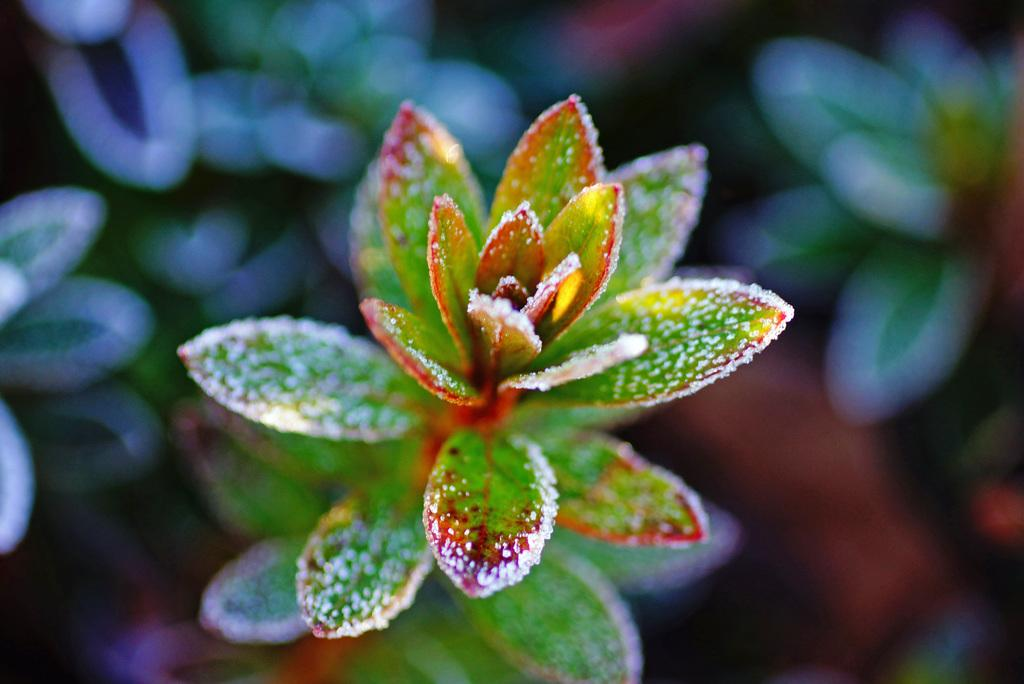What type of plant is represented in the image? There are a few leaves of a plant in the image. What type of cable can be seen connecting the leaves in the image? There is no cable present in the image; it features only the leaves of a plant. What type of vegetable is visible among the leaves in the image? There is no vegetable, such as celery, visible among the leaves in the image. 